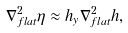<formula> <loc_0><loc_0><loc_500><loc_500>\nabla _ { f l a t } ^ { 2 } \eta \approx h _ { y } \nabla _ { f l a t } ^ { 2 } h ,</formula> 